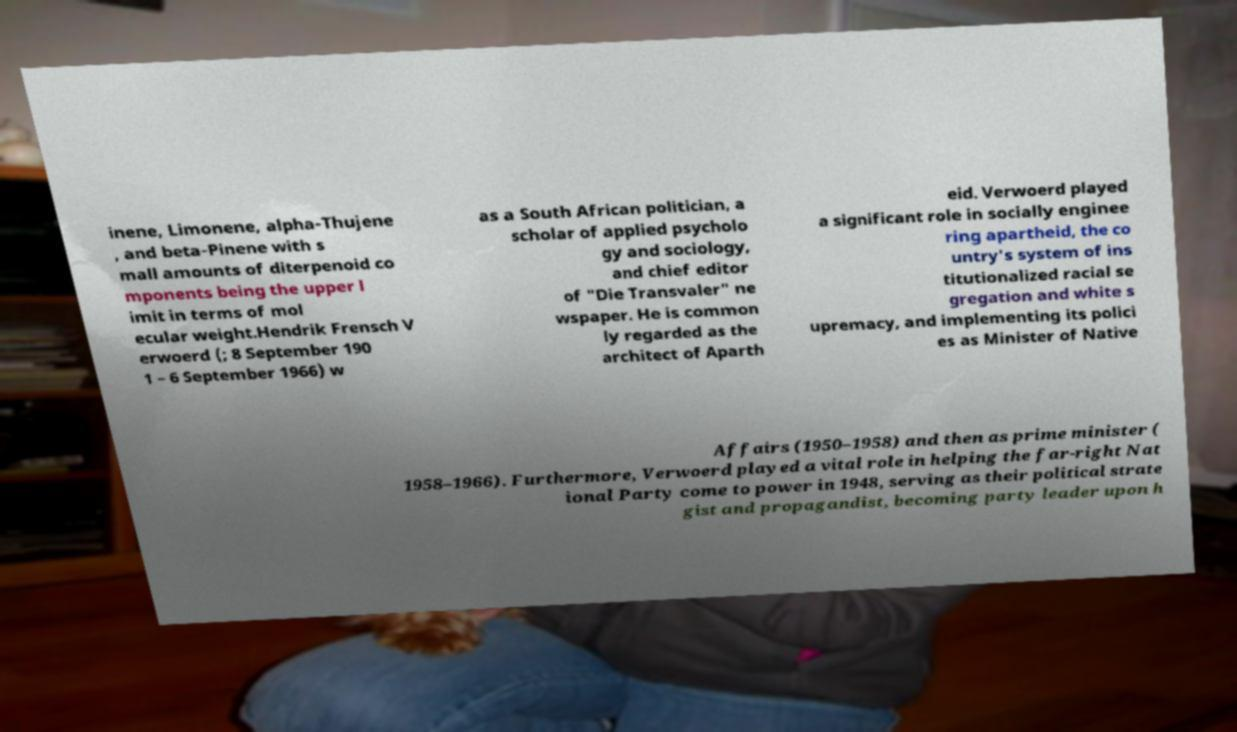There's text embedded in this image that I need extracted. Can you transcribe it verbatim? inene, Limonene, alpha-Thujene , and beta-Pinene with s mall amounts of diterpenoid co mponents being the upper l imit in terms of mol ecular weight.Hendrik Frensch V erwoerd (; 8 September 190 1 – 6 September 1966) w as a South African politician, a scholar of applied psycholo gy and sociology, and chief editor of "Die Transvaler" ne wspaper. He is common ly regarded as the architect of Aparth eid. Verwoerd played a significant role in socially enginee ring apartheid, the co untry's system of ins titutionalized racial se gregation and white s upremacy, and implementing its polici es as Minister of Native Affairs (1950–1958) and then as prime minister ( 1958–1966). Furthermore, Verwoerd played a vital role in helping the far-right Nat ional Party come to power in 1948, serving as their political strate gist and propagandist, becoming party leader upon h 